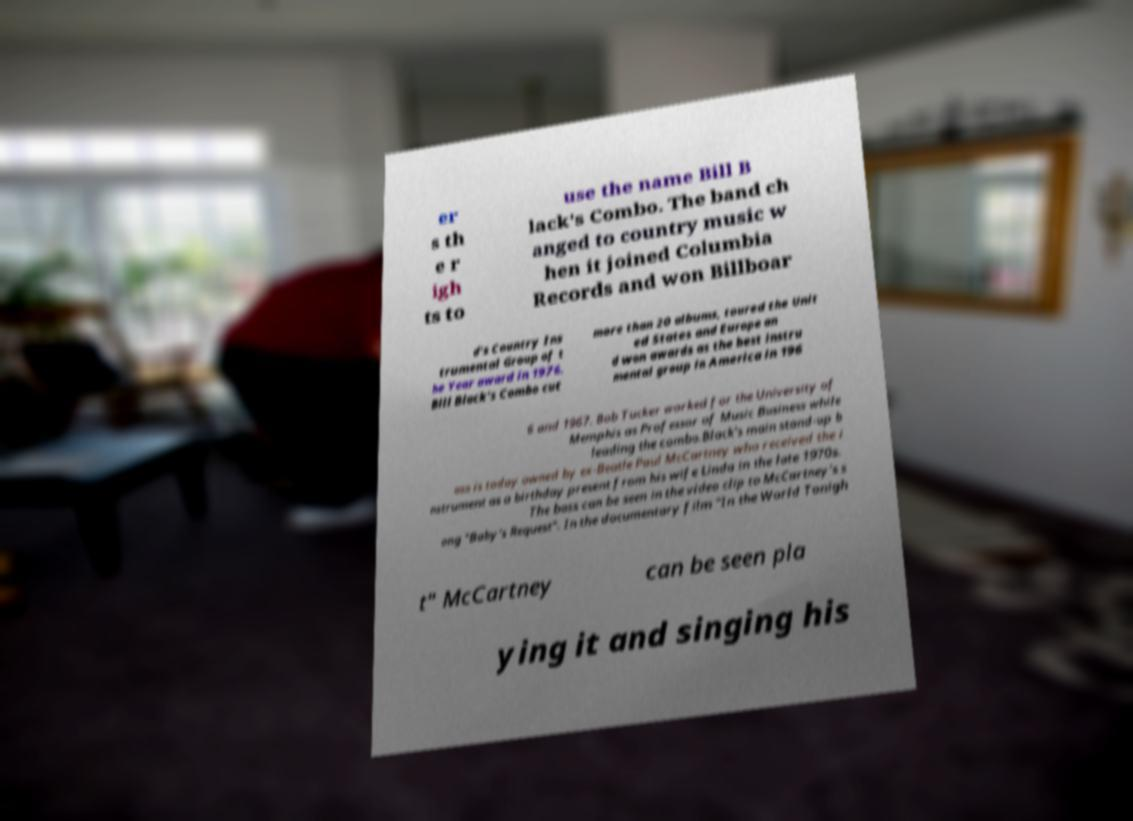There's text embedded in this image that I need extracted. Can you transcribe it verbatim? er s th e r igh ts to use the name Bill B lack's Combo. The band ch anged to country music w hen it joined Columbia Records and won Billboar d's Country Ins trumental Group of t he Year award in 1976. Bill Black's Combo cut more than 20 albums, toured the Unit ed States and Europe an d won awards as the best instru mental group in America in 196 6 and 1967. Bob Tucker worked for the University of Memphis as Professor of Music Business while leading the combo.Black's main stand-up b ass is today owned by ex-Beatle Paul McCartney who received the i nstrument as a birthday present from his wife Linda in the late 1970s. The bass can be seen in the video clip to McCartney's s ong "Baby's Request". In the documentary film "In the World Tonigh t" McCartney can be seen pla ying it and singing his 